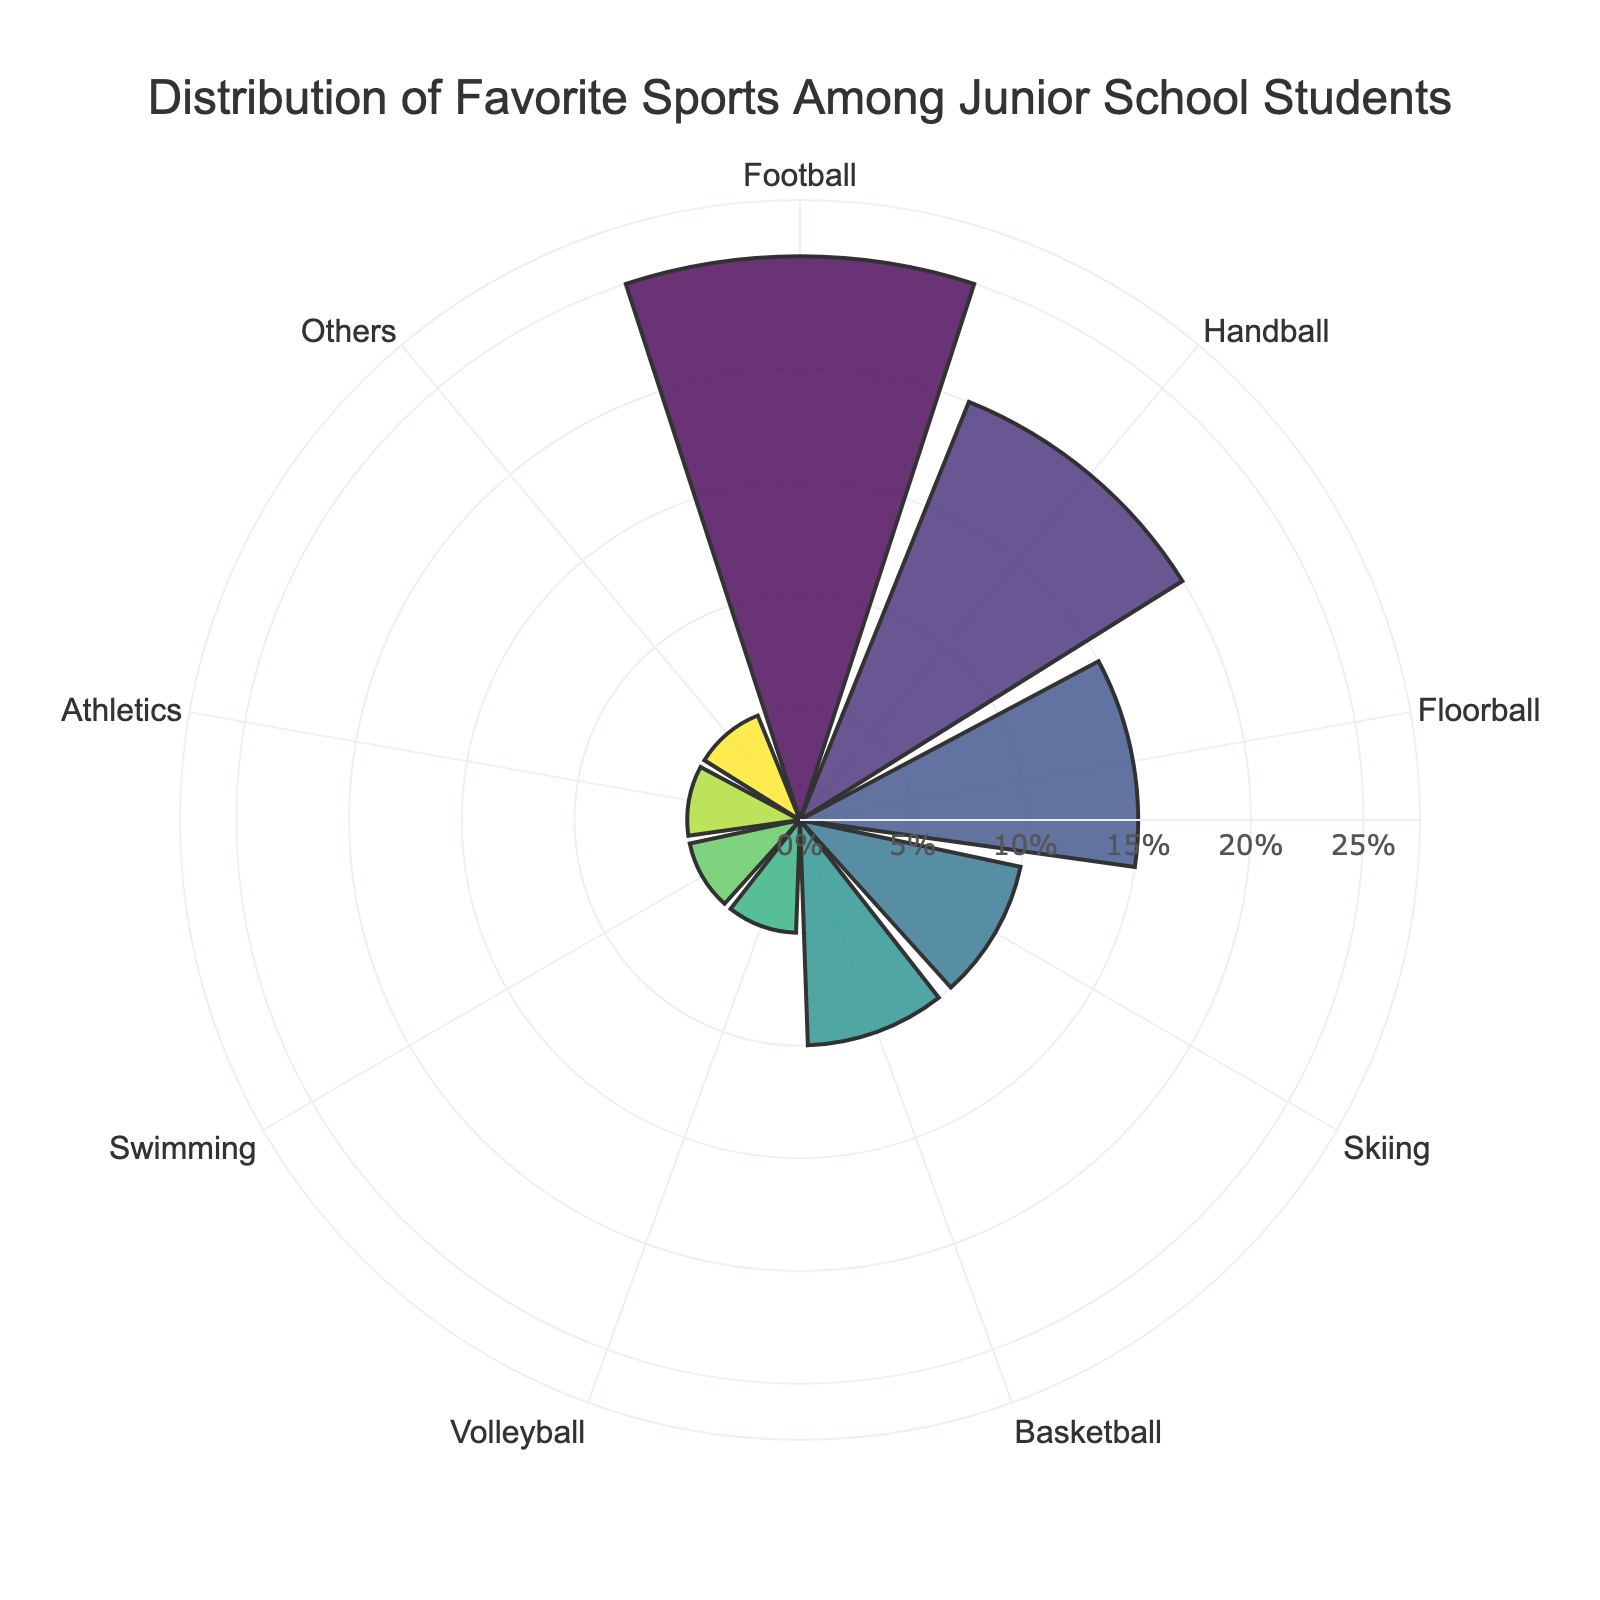What is the title of the chart? The title is written at the top center of the chart. It reads: "Distribution of Favorite Sports Among Junior School Students"
Answer: Distribution of Favorite Sports Among Junior School Students Which sport is the most favored among the students? The longest radial bar in the rose chart corresponds to the sport with the highest percentage. Football has the longest bar.
Answer: Football How many sports have a percentage favorability of 5%? By looking at the radial bars, we see that Volleyball, Swimming, Athletics, and Others each have a bar length corresponding to 5%. Count these bars.
Answer: 4 By how much does the favorability of Football exceed that of Handball? The bar for Football is at 25% and Handball is at 20%. Subtract the percentage of Handball from Football: 25% - 20%.
Answer: 5% What is the combined percentage favorability of Basketball and Volleyball? The radial bar for Basketball shows 10% and for Volleyball shows 5%. Add these percentages: 10% + 5%.
Answer: 15% Is there a sport with the same favorability percentage as Swimming? Look at the radial bar lengths and find the one that matches Swimming's 5%, which is also shared by Volleyball, Athletics, and Others.
Answer: Yes Which sport has a higher favorability: Floorball or Skiing? Compare the radial bar lengths for Floorball and Skiing. Floorball has 15% while Skiing has 10%.
Answer: Floorball What is the range of percentages displayed in the chart? Identify the smallest and largest percentages from the radial bars. The smallest is 5% (Volleyball, Swimming, Athletics, Others) and the largest is 25% (Football). Subtract the smallest from the largest: 25% - 5%.
Answer: 20% What percentage is allocated to sports not specified in the main categories? Look for the bar labeled "Others". It shows a percentage of 5%.
Answer: 5% How many sports have a favorability percentage greater than 10%? Count the sports with bars longer than the 10% mark. These are Football (25%), Handball (20%), and Floorball (15%).
Answer: 3 